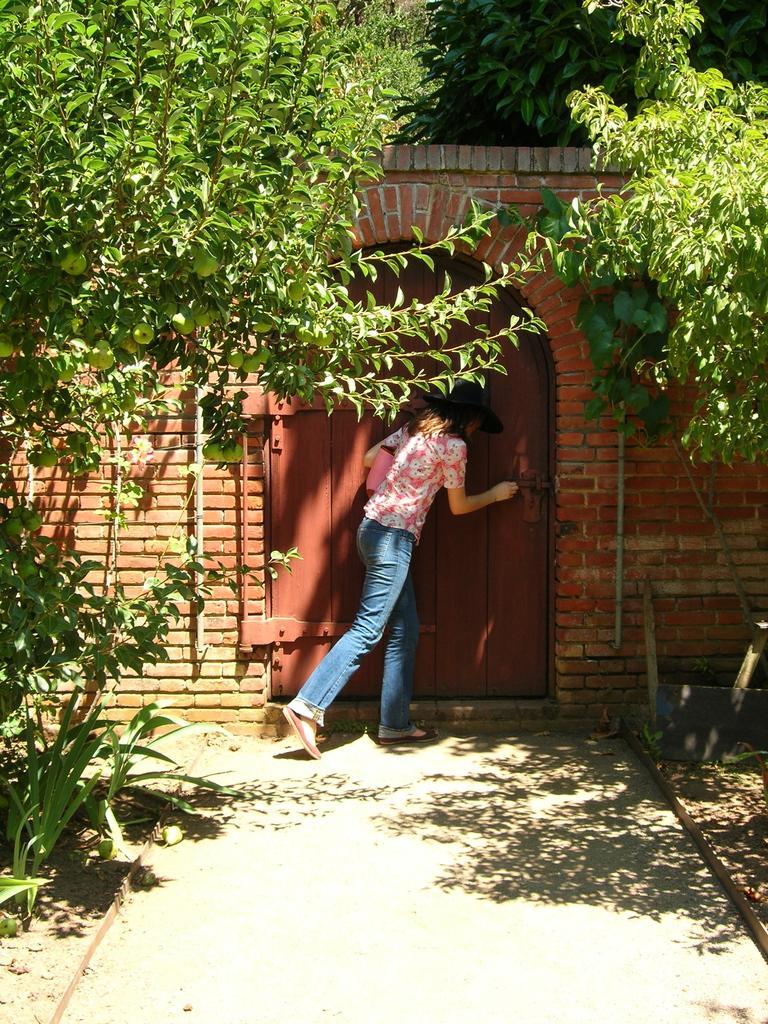In one or two sentences, can you explain what this image depicts? In this image we can see a woman standing near the gate, trees, fruits, shrubs and a wall. 